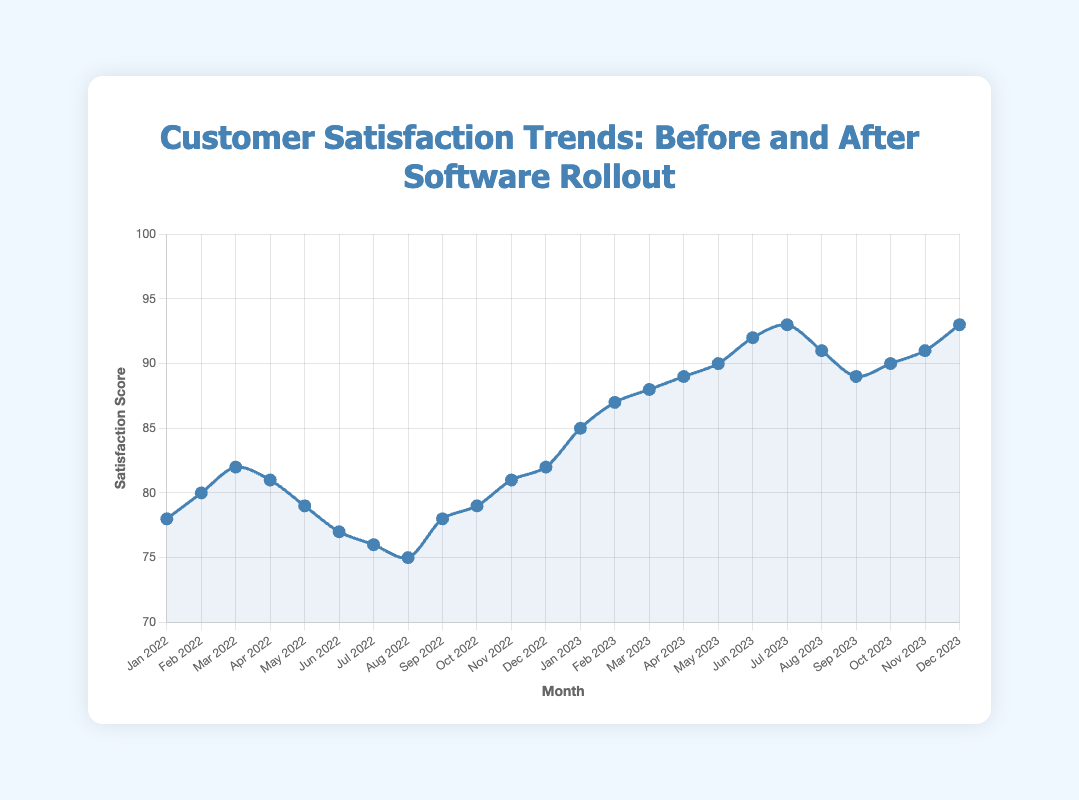What's the trend in customer satisfaction scores from January 2022 to December 2022? The satisfaction score started at 78 in January 2022, peaked at 82 in March 2022, and then fluctuated, ending at 82 in December 2022.
Answer: Fluctuating with a slight overall increase How did the customer satisfaction score change immediately after the new software rollout in January 2023? The customer satisfaction score increased from 82 in December 2022 to 85 in January 2023, showing an immediate improvement after the rollout.
Answer: Increased What is the difference in customer satisfaction scores between the highest point in 2023 and the highest point in 2022? The highest point in 2022 is 82 (in March and December 2022), and the highest in 2023 is 93 (in December 2023). The difference is 93 - 82 = 11.
Answer: 11 Was there any month in 2023 where the customer satisfaction score decreased compared to the previous month? Yes, from September 2023 (93) to October 2023 (91), and from October 2023 (91) to November 2023 (89).
Answer: Yes What was the average customer satisfaction score for the year 2022? Sum of scores for 2022: 78 + 80 + 82 + 81 + 79 + 77 + 76 + 75 + 78 + 79 + 81 + 82 = 948. Average = 948 / 12 = 79.
Answer: 79 Compare the customer satisfaction scores before and after the new software rollout using the average scores for 2022 and 2023. Average for 2022 is 79, and the average from January to December 2023: (85 + 87 + 88 + 89 + 90 + 92 + 93 + 91 + 89 + 90 + 91 + 93) = 1068 / 12 = 89. The average score increased by 10 points after the rollout.
Answer: Increased by 10 points How many months after the software rollout did the customer satisfaction score reach its highest point? The highest score in 2023 is 93, which occurred in July 2023 and December 2023. The software rollout happened in January 2023, so the highest score was reached in the 7th and 12th months.
Answer: 7th and 12th months Looking at the line color and point characteristics, how can you visually distinguish between the satisfaction scores from 2022 and 2023? The line is a consistent blue color, but the vertical annotation line at the software rollout in January 2023 helps to distinguish scores before and after this point visually.
Answer: Vertical annotation line in January 2023 After how many months of the new software rollout did the customer satisfaction score start to increase steadily? The score started increasing steadily from February 2023 (87), just one month after the new software rollout in January 2023 (85).
Answer: 1 month 